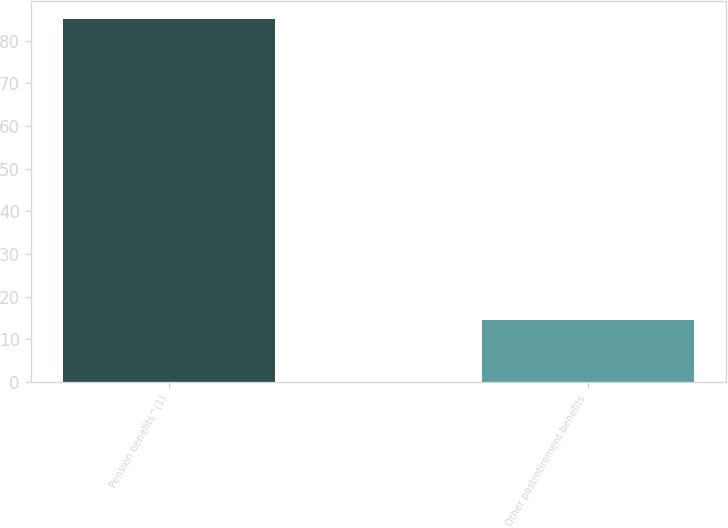Convert chart. <chart><loc_0><loc_0><loc_500><loc_500><bar_chart><fcel>Pension benefits^(1)<fcel>Other postretirement benefits<nl><fcel>85.2<fcel>14.4<nl></chart> 